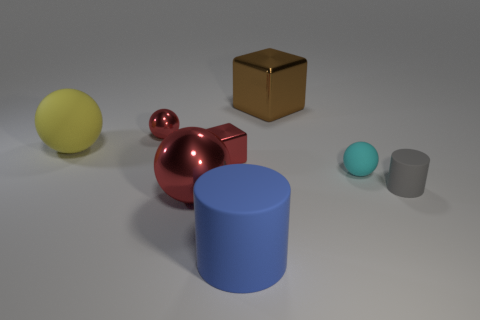Subtract all large yellow matte balls. How many balls are left? 3 Add 1 large things. How many objects exist? 9 Subtract all gray cubes. How many red balls are left? 2 Subtract all blue cylinders. How many cylinders are left? 1 Subtract all cubes. How many objects are left? 6 Subtract 2 cubes. How many cubes are left? 0 Subtract 0 green spheres. How many objects are left? 8 Subtract all red blocks. Subtract all purple cylinders. How many blocks are left? 1 Subtract all small cyan matte blocks. Subtract all cyan balls. How many objects are left? 7 Add 5 large matte balls. How many large matte balls are left? 6 